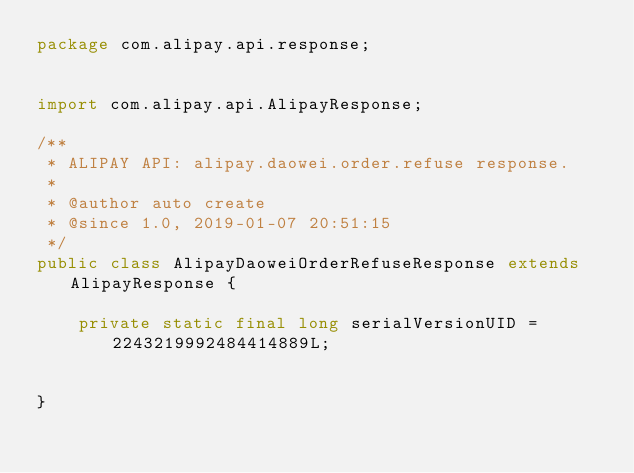<code> <loc_0><loc_0><loc_500><loc_500><_Java_>package com.alipay.api.response;


import com.alipay.api.AlipayResponse;

/**
 * ALIPAY API: alipay.daowei.order.refuse response.
 *
 * @author auto create
 * @since 1.0, 2019-01-07 20:51:15
 */
public class AlipayDaoweiOrderRefuseResponse extends AlipayResponse {

    private static final long serialVersionUID = 2243219992484414889L;


}
</code> 